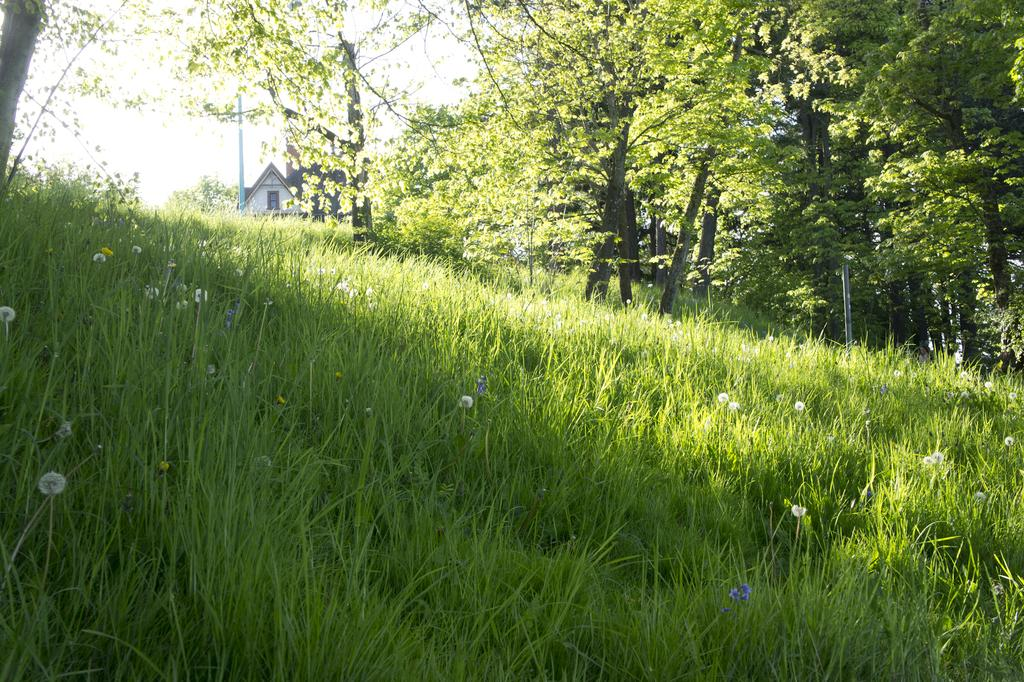What type of vegetation is present in the image? There is grass in the image. What other natural elements can be seen in the image? There are trees in the image. What man-made object is present in the image? There is a pole in the image. What type of structure is visible in the image? There is a house in the image. How many casts are present in the image? There is no mention of casts in the image, so we cannot determine the number of casts. What type of destruction can be seen in the image? There is no destruction present in the image; it features grass, trees, a pole, and a house. 